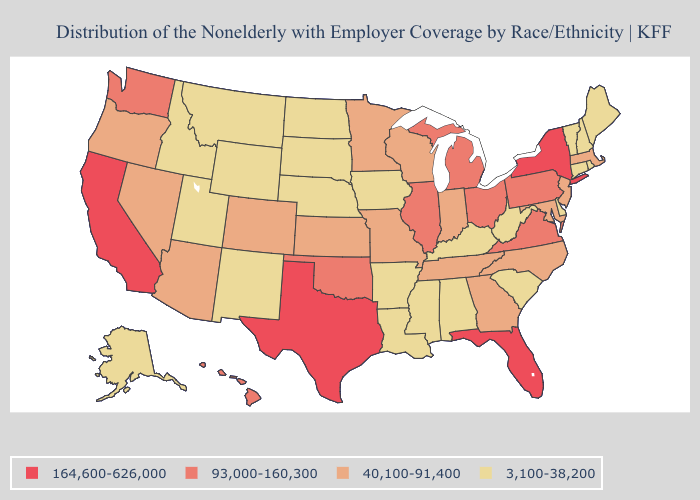Which states have the lowest value in the South?
Be succinct. Alabama, Arkansas, Delaware, Kentucky, Louisiana, Mississippi, South Carolina, West Virginia. What is the highest value in the South ?
Keep it brief. 164,600-626,000. What is the highest value in states that border North Carolina?
Be succinct. 93,000-160,300. What is the value of California?
Answer briefly. 164,600-626,000. What is the highest value in the Northeast ?
Quick response, please. 164,600-626,000. Does Alabama have the same value as Indiana?
Concise answer only. No. Among the states that border Texas , which have the lowest value?
Be succinct. Arkansas, Louisiana, New Mexico. Name the states that have a value in the range 93,000-160,300?
Keep it brief. Hawaii, Illinois, Michigan, Ohio, Oklahoma, Pennsylvania, Virginia, Washington. Name the states that have a value in the range 40,100-91,400?
Give a very brief answer. Arizona, Colorado, Georgia, Indiana, Kansas, Maryland, Massachusetts, Minnesota, Missouri, Nevada, New Jersey, North Carolina, Oregon, Tennessee, Wisconsin. What is the value of Tennessee?
Quick response, please. 40,100-91,400. Does California have the highest value in the West?
Give a very brief answer. Yes. What is the highest value in the South ?
Be succinct. 164,600-626,000. Which states have the lowest value in the South?
Give a very brief answer. Alabama, Arkansas, Delaware, Kentucky, Louisiana, Mississippi, South Carolina, West Virginia. Among the states that border Nebraska , does Colorado have the highest value?
Be succinct. Yes. 